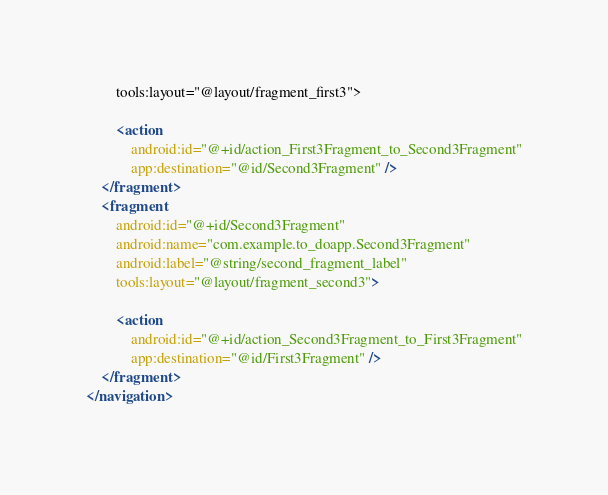<code> <loc_0><loc_0><loc_500><loc_500><_XML_>        tools:layout="@layout/fragment_first3">

        <action
            android:id="@+id/action_First3Fragment_to_Second3Fragment"
            app:destination="@id/Second3Fragment" />
    </fragment>
    <fragment
        android:id="@+id/Second3Fragment"
        android:name="com.example.to_doapp.Second3Fragment"
        android:label="@string/second_fragment_label"
        tools:layout="@layout/fragment_second3">

        <action
            android:id="@+id/action_Second3Fragment_to_First3Fragment"
            app:destination="@id/First3Fragment" />
    </fragment>
</navigation></code> 